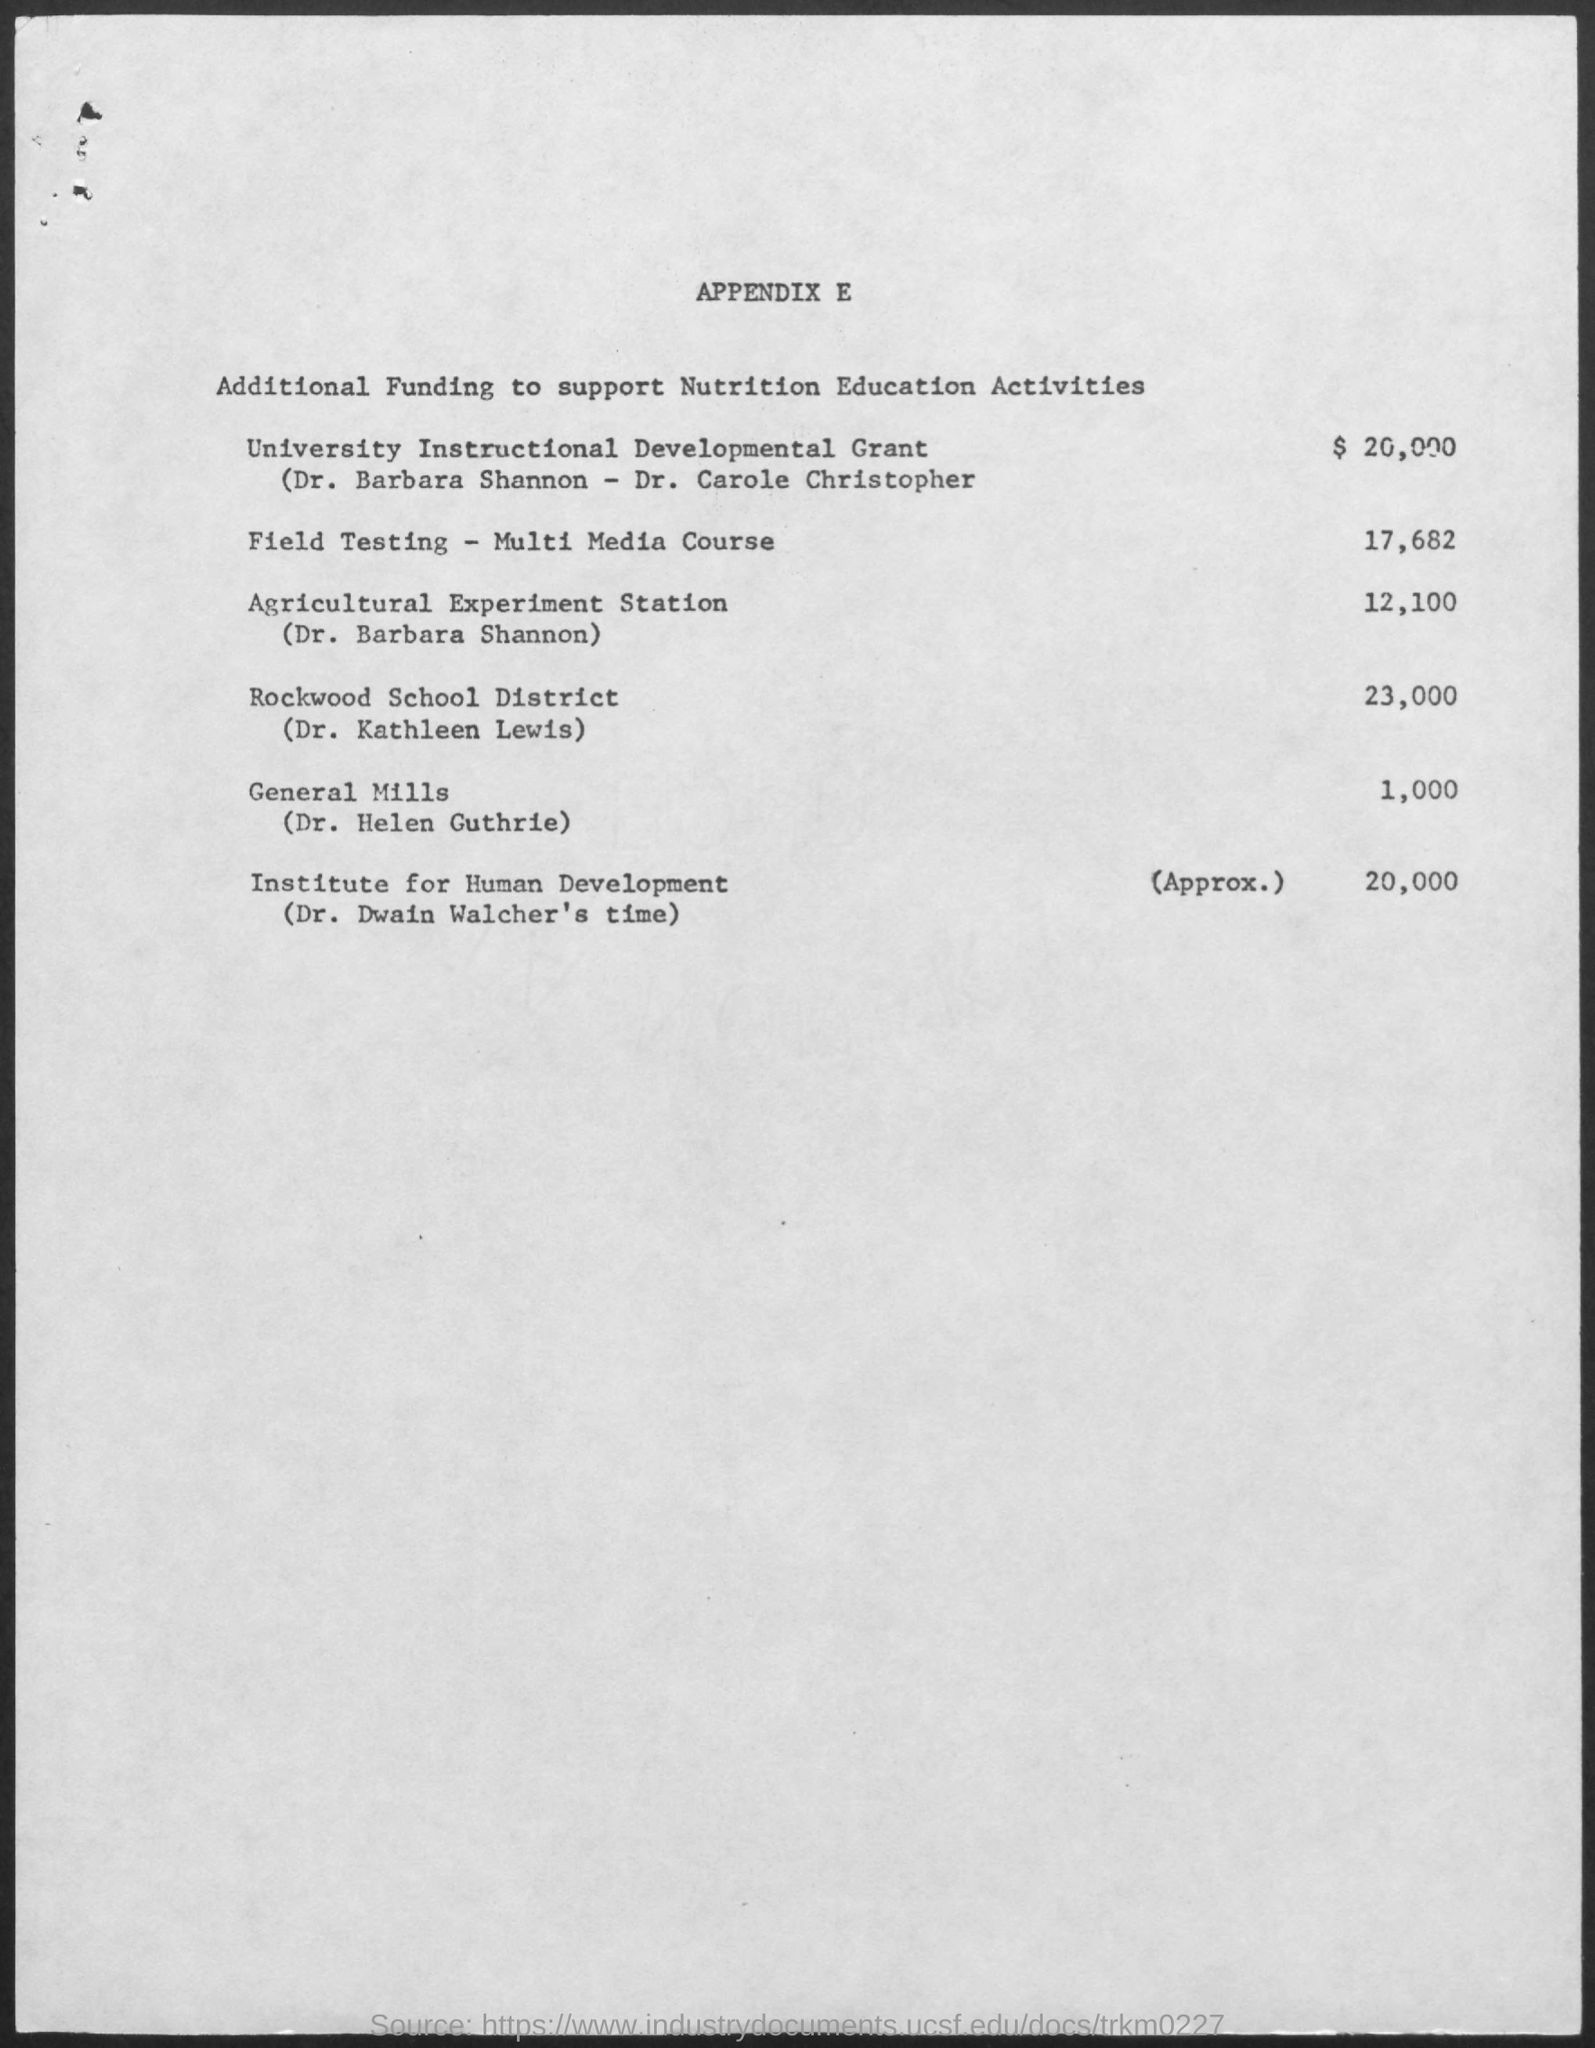What is the cost of Field Testing - Multi media Course ?
Ensure brevity in your answer.  17,682. What is the cost of Agricultural Experiment Station?
Ensure brevity in your answer.  12,100. 